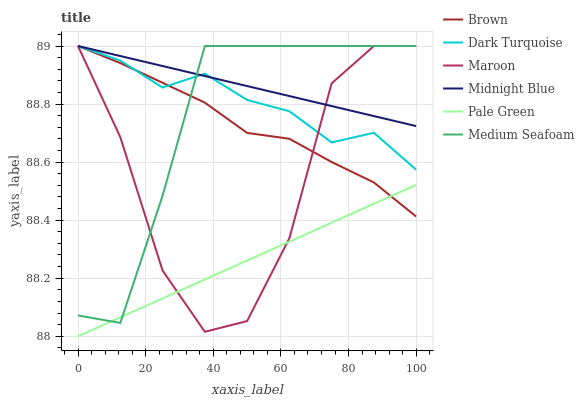Does Dark Turquoise have the minimum area under the curve?
Answer yes or no. No. Does Dark Turquoise have the maximum area under the curve?
Answer yes or no. No. Is Dark Turquoise the smoothest?
Answer yes or no. No. Is Dark Turquoise the roughest?
Answer yes or no. No. Does Dark Turquoise have the lowest value?
Answer yes or no. No. Does Pale Green have the highest value?
Answer yes or no. No. Is Pale Green less than Dark Turquoise?
Answer yes or no. Yes. Is Midnight Blue greater than Pale Green?
Answer yes or no. Yes. Does Pale Green intersect Dark Turquoise?
Answer yes or no. No. 